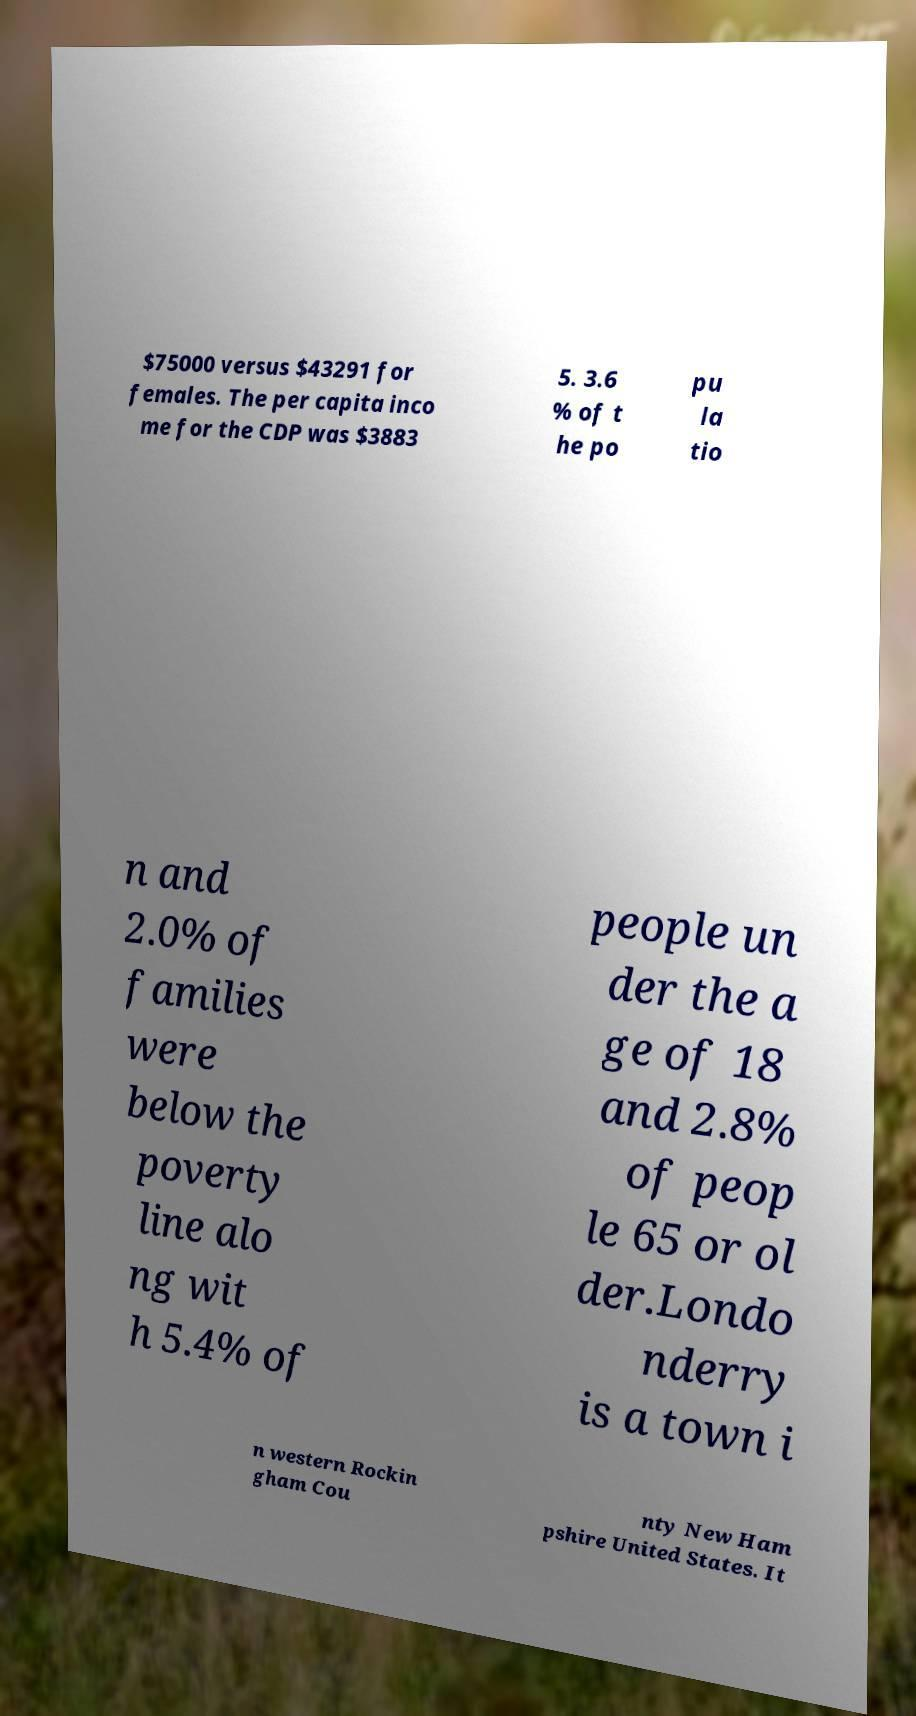Please identify and transcribe the text found in this image. $75000 versus $43291 for females. The per capita inco me for the CDP was $3883 5. 3.6 % of t he po pu la tio n and 2.0% of families were below the poverty line alo ng wit h 5.4% of people un der the a ge of 18 and 2.8% of peop le 65 or ol der.Londo nderry is a town i n western Rockin gham Cou nty New Ham pshire United States. It 